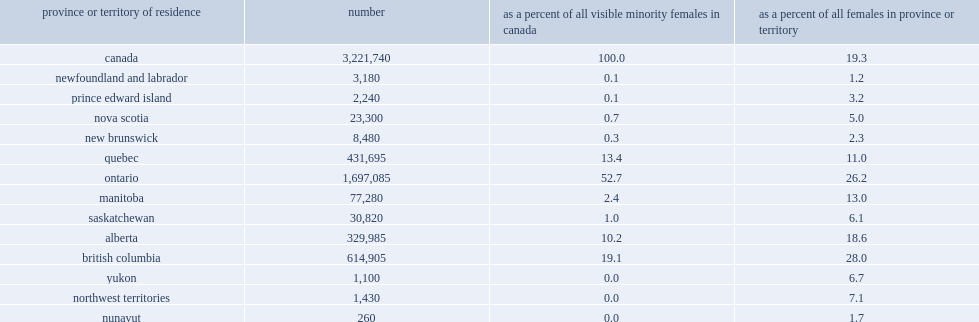What the percentage of ontario was home to visible minority females? 52.7. Visible minority representation in the total female population was high in british columbia, what was the percentage of females belonged to a visible minority group? 28.0. Visible minority representation in the total female population was high in ontario, what was the percentage of females belonged to a visible minority group? 26.2. What was the percentage of the female population identified as a visible minority in alberta? 18.6. What was the percentage of the female population identified as a visible minority in quebec? 11.0. What was the proportion of the female visible minority population living in manitoba? 2.4. What was the proportion of females in manitoba who identified as a visible minority? 13.0. 